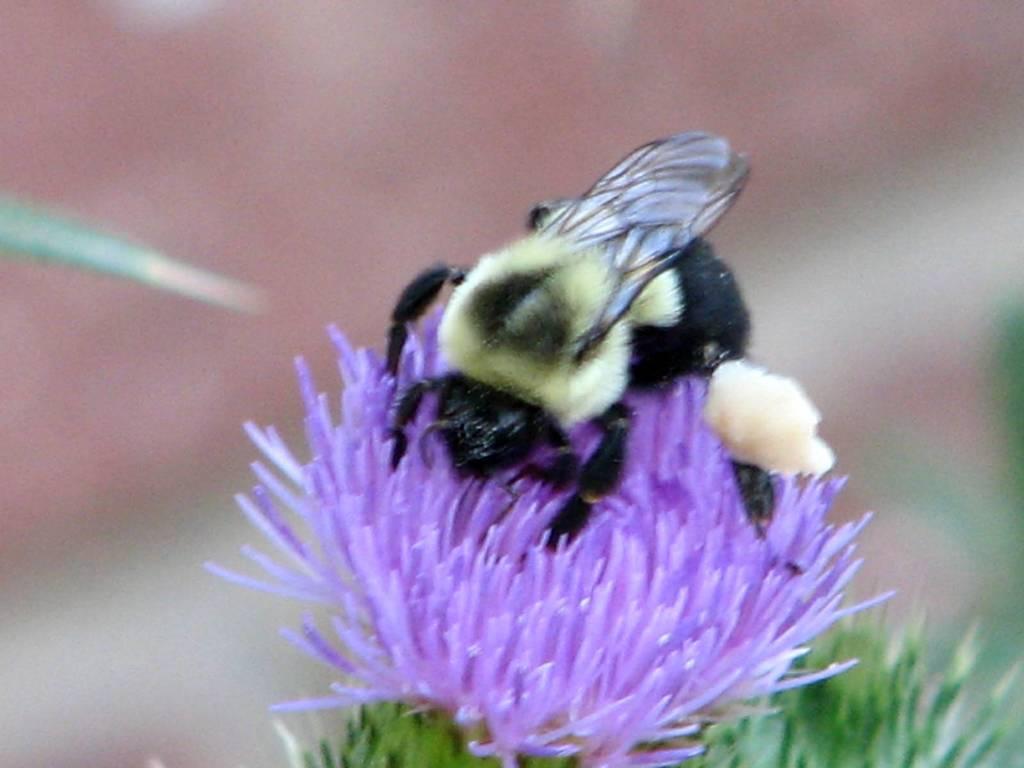Could you give a brief overview of what you see in this image? On this flower there is an insect. Background it is blur. 